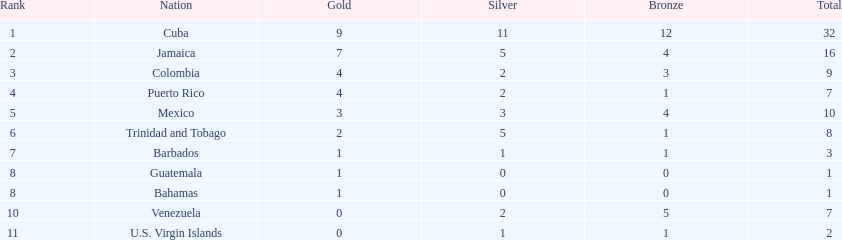In the games, which countries participated? Cuba, Jamaica, Colombia, Puerto Rico, Mexico, Trinidad and Tobago, Barbados, Guatemala, Bahamas, Venezuela, U.S. Virgin Islands. How many silver medals were won by each? 11, 5, 2, 2, 3, 5, 1, 0, 0, 2, 1. Which team had the highest silver medal count? Cuba. 